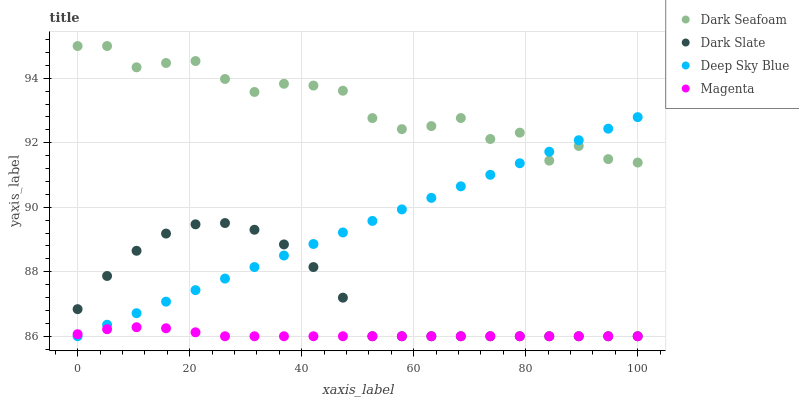Does Magenta have the minimum area under the curve?
Answer yes or no. Yes. Does Dark Seafoam have the maximum area under the curve?
Answer yes or no. Yes. Does Dark Seafoam have the minimum area under the curve?
Answer yes or no. No. Does Magenta have the maximum area under the curve?
Answer yes or no. No. Is Deep Sky Blue the smoothest?
Answer yes or no. Yes. Is Dark Seafoam the roughest?
Answer yes or no. Yes. Is Magenta the smoothest?
Answer yes or no. No. Is Magenta the roughest?
Answer yes or no. No. Does Dark Slate have the lowest value?
Answer yes or no. Yes. Does Dark Seafoam have the lowest value?
Answer yes or no. No. Does Dark Seafoam have the highest value?
Answer yes or no. Yes. Does Magenta have the highest value?
Answer yes or no. No. Is Dark Slate less than Dark Seafoam?
Answer yes or no. Yes. Is Dark Seafoam greater than Magenta?
Answer yes or no. Yes. Does Deep Sky Blue intersect Dark Seafoam?
Answer yes or no. Yes. Is Deep Sky Blue less than Dark Seafoam?
Answer yes or no. No. Is Deep Sky Blue greater than Dark Seafoam?
Answer yes or no. No. Does Dark Slate intersect Dark Seafoam?
Answer yes or no. No. 